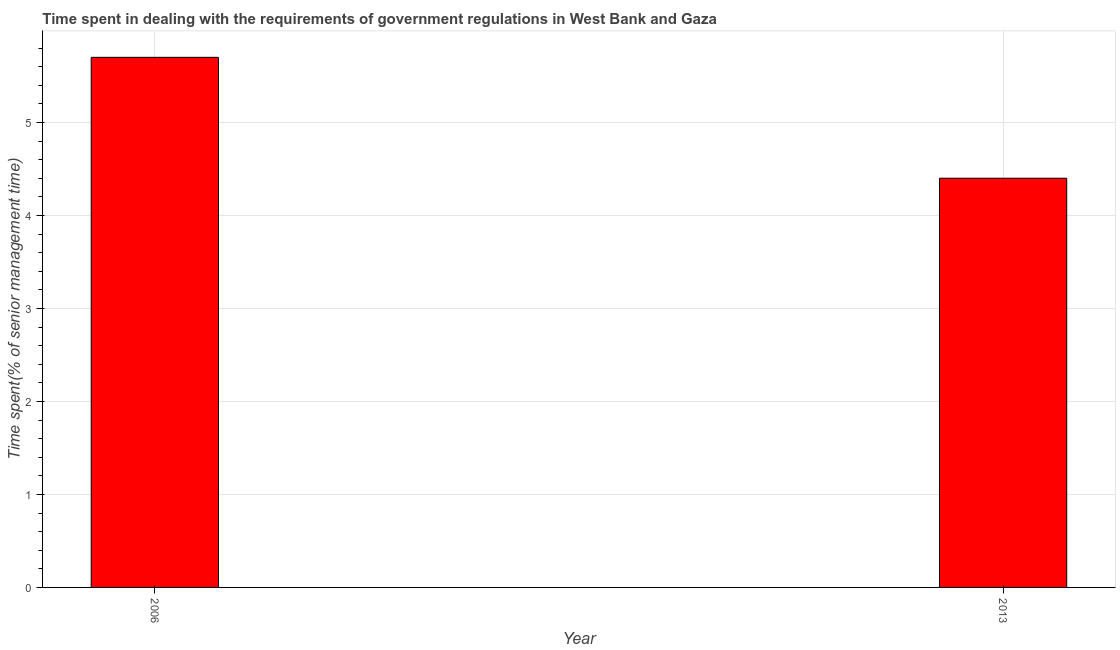What is the title of the graph?
Ensure brevity in your answer.  Time spent in dealing with the requirements of government regulations in West Bank and Gaza. What is the label or title of the X-axis?
Provide a short and direct response. Year. What is the label or title of the Y-axis?
Your answer should be very brief. Time spent(% of senior management time). What is the time spent in dealing with government regulations in 2006?
Offer a very short reply. 5.7. In which year was the time spent in dealing with government regulations maximum?
Ensure brevity in your answer.  2006. In which year was the time spent in dealing with government regulations minimum?
Your answer should be compact. 2013. What is the sum of the time spent in dealing with government regulations?
Keep it short and to the point. 10.1. What is the average time spent in dealing with government regulations per year?
Provide a short and direct response. 5.05. What is the median time spent in dealing with government regulations?
Make the answer very short. 5.05. What is the ratio of the time spent in dealing with government regulations in 2006 to that in 2013?
Provide a short and direct response. 1.29. Is the time spent in dealing with government regulations in 2006 less than that in 2013?
Provide a succinct answer. No. In how many years, is the time spent in dealing with government regulations greater than the average time spent in dealing with government regulations taken over all years?
Keep it short and to the point. 1. How many bars are there?
Provide a short and direct response. 2. Are the values on the major ticks of Y-axis written in scientific E-notation?
Provide a short and direct response. No. What is the difference between the Time spent(% of senior management time) in 2006 and 2013?
Your answer should be very brief. 1.3. What is the ratio of the Time spent(% of senior management time) in 2006 to that in 2013?
Give a very brief answer. 1.29. 